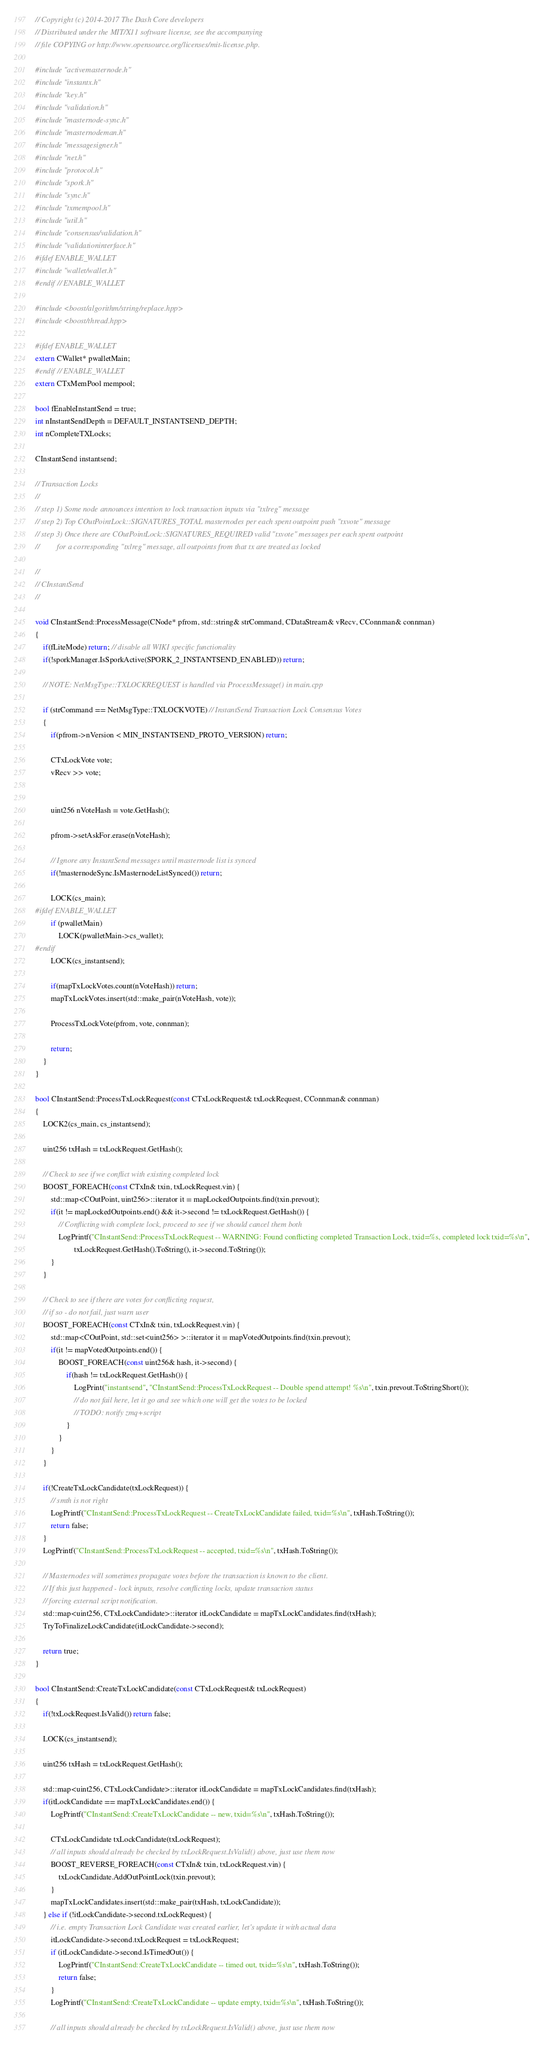<code> <loc_0><loc_0><loc_500><loc_500><_C++_>// Copyright (c) 2014-2017 The Dash Core developers
// Distributed under the MIT/X11 software license, see the accompanying
// file COPYING or http://www.opensource.org/licenses/mit-license.php.

#include "activemasternode.h"
#include "instantx.h"
#include "key.h"
#include "validation.h"
#include "masternode-sync.h"
#include "masternodeman.h"
#include "messagesigner.h"
#include "net.h"
#include "protocol.h"
#include "spork.h"
#include "sync.h"
#include "txmempool.h"
#include "util.h"
#include "consensus/validation.h"
#include "validationinterface.h"
#ifdef ENABLE_WALLET
#include "wallet/wallet.h"
#endif // ENABLE_WALLET

#include <boost/algorithm/string/replace.hpp>
#include <boost/thread.hpp>

#ifdef ENABLE_WALLET
extern CWallet* pwalletMain;
#endif // ENABLE_WALLET
extern CTxMemPool mempool;

bool fEnableInstantSend = true;
int nInstantSendDepth = DEFAULT_INSTANTSEND_DEPTH;
int nCompleteTXLocks;

CInstantSend instantsend;

// Transaction Locks
//
// step 1) Some node announces intention to lock transaction inputs via "txlreg" message
// step 2) Top COutPointLock::SIGNATURES_TOTAL masternodes per each spent outpoint push "txvote" message
// step 3) Once there are COutPointLock::SIGNATURES_REQUIRED valid "txvote" messages per each spent outpoint
//         for a corresponding "txlreg" message, all outpoints from that tx are treated as locked

//
// CInstantSend
//

void CInstantSend::ProcessMessage(CNode* pfrom, std::string& strCommand, CDataStream& vRecv, CConnman& connman)
{
    if(fLiteMode) return; // disable all WIKI specific functionality
    if(!sporkManager.IsSporkActive(SPORK_2_INSTANTSEND_ENABLED)) return;

    // NOTE: NetMsgType::TXLOCKREQUEST is handled via ProcessMessage() in main.cpp

    if (strCommand == NetMsgType::TXLOCKVOTE) // InstantSend Transaction Lock Consensus Votes
    {
        if(pfrom->nVersion < MIN_INSTANTSEND_PROTO_VERSION) return;

        CTxLockVote vote;
        vRecv >> vote;


        uint256 nVoteHash = vote.GetHash();

        pfrom->setAskFor.erase(nVoteHash);

        // Ignore any InstantSend messages until masternode list is synced
        if(!masternodeSync.IsMasternodeListSynced()) return;

        LOCK(cs_main);
#ifdef ENABLE_WALLET
        if (pwalletMain)
            LOCK(pwalletMain->cs_wallet);
#endif
        LOCK(cs_instantsend);

        if(mapTxLockVotes.count(nVoteHash)) return;
        mapTxLockVotes.insert(std::make_pair(nVoteHash, vote));

        ProcessTxLockVote(pfrom, vote, connman);

        return;
    }
}

bool CInstantSend::ProcessTxLockRequest(const CTxLockRequest& txLockRequest, CConnman& connman)
{
    LOCK2(cs_main, cs_instantsend);

    uint256 txHash = txLockRequest.GetHash();

    // Check to see if we conflict with existing completed lock
    BOOST_FOREACH(const CTxIn& txin, txLockRequest.vin) {
        std::map<COutPoint, uint256>::iterator it = mapLockedOutpoints.find(txin.prevout);
        if(it != mapLockedOutpoints.end() && it->second != txLockRequest.GetHash()) {
            // Conflicting with complete lock, proceed to see if we should cancel them both
            LogPrintf("CInstantSend::ProcessTxLockRequest -- WARNING: Found conflicting completed Transaction Lock, txid=%s, completed lock txid=%s\n",
                    txLockRequest.GetHash().ToString(), it->second.ToString());
        }
    }

    // Check to see if there are votes for conflicting request,
    // if so - do not fail, just warn user
    BOOST_FOREACH(const CTxIn& txin, txLockRequest.vin) {
        std::map<COutPoint, std::set<uint256> >::iterator it = mapVotedOutpoints.find(txin.prevout);
        if(it != mapVotedOutpoints.end()) {
            BOOST_FOREACH(const uint256& hash, it->second) {
                if(hash != txLockRequest.GetHash()) {
                    LogPrint("instantsend", "CInstantSend::ProcessTxLockRequest -- Double spend attempt! %s\n", txin.prevout.ToStringShort());
                    // do not fail here, let it go and see which one will get the votes to be locked
                    // TODO: notify zmq+script
                }
            }
        }
    }

    if(!CreateTxLockCandidate(txLockRequest)) {
        // smth is not right
        LogPrintf("CInstantSend::ProcessTxLockRequest -- CreateTxLockCandidate failed, txid=%s\n", txHash.ToString());
        return false;
    }
    LogPrintf("CInstantSend::ProcessTxLockRequest -- accepted, txid=%s\n", txHash.ToString());

    // Masternodes will sometimes propagate votes before the transaction is known to the client.
    // If this just happened - lock inputs, resolve conflicting locks, update transaction status
    // forcing external script notification.
    std::map<uint256, CTxLockCandidate>::iterator itLockCandidate = mapTxLockCandidates.find(txHash);
    TryToFinalizeLockCandidate(itLockCandidate->second);

    return true;
}

bool CInstantSend::CreateTxLockCandidate(const CTxLockRequest& txLockRequest)
{
    if(!txLockRequest.IsValid()) return false;

    LOCK(cs_instantsend);

    uint256 txHash = txLockRequest.GetHash();

    std::map<uint256, CTxLockCandidate>::iterator itLockCandidate = mapTxLockCandidates.find(txHash);
    if(itLockCandidate == mapTxLockCandidates.end()) {
        LogPrintf("CInstantSend::CreateTxLockCandidate -- new, txid=%s\n", txHash.ToString());

        CTxLockCandidate txLockCandidate(txLockRequest);
        // all inputs should already be checked by txLockRequest.IsValid() above, just use them now
        BOOST_REVERSE_FOREACH(const CTxIn& txin, txLockRequest.vin) {
            txLockCandidate.AddOutPointLock(txin.prevout);
        }
        mapTxLockCandidates.insert(std::make_pair(txHash, txLockCandidate));
    } else if (!itLockCandidate->second.txLockRequest) {
        // i.e. empty Transaction Lock Candidate was created earlier, let's update it with actual data
        itLockCandidate->second.txLockRequest = txLockRequest;
        if (itLockCandidate->second.IsTimedOut()) {
            LogPrintf("CInstantSend::CreateTxLockCandidate -- timed out, txid=%s\n", txHash.ToString());
            return false;
        }
        LogPrintf("CInstantSend::CreateTxLockCandidate -- update empty, txid=%s\n", txHash.ToString());

        // all inputs should already be checked by txLockRequest.IsValid() above, just use them now</code> 